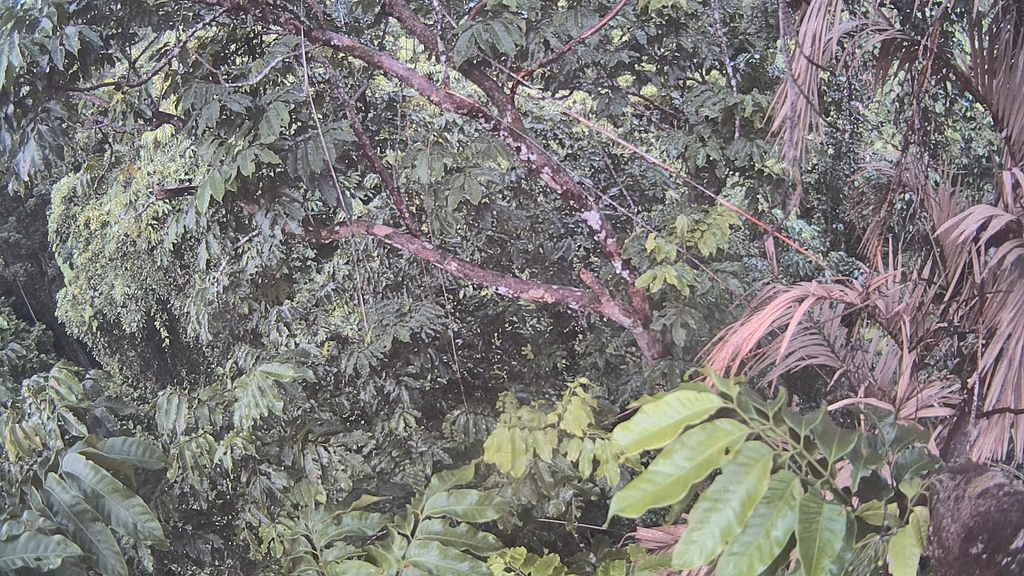What is located in the middle of the image? There are trees in the middle of the image. What type of cup is being used to connect the trees in the image? There is no cup or connection between the trees in the image; they are simply standing in the middle of the image. 